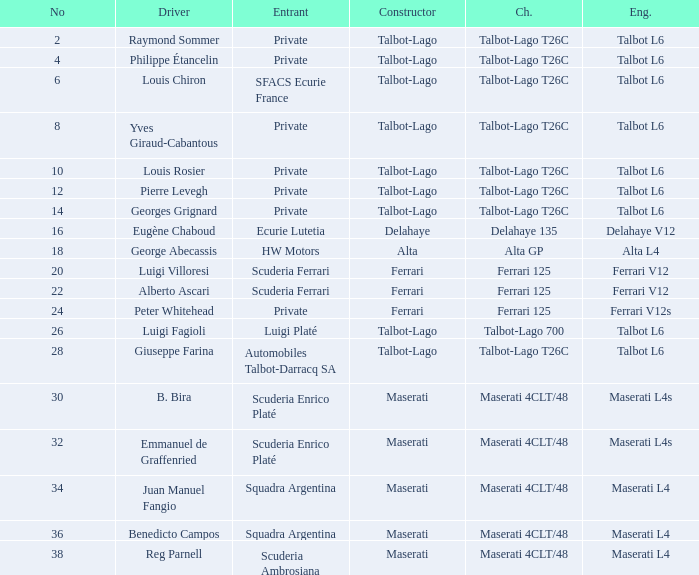Name the constructor for number 10 Talbot-Lago. 